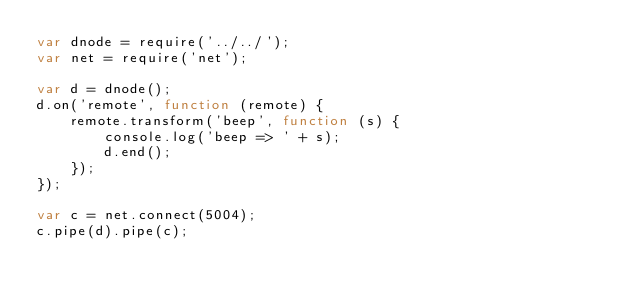<code> <loc_0><loc_0><loc_500><loc_500><_JavaScript_>var dnode = require('../../');
var net = require('net');

var d = dnode();
d.on('remote', function (remote) {
    remote.transform('beep', function (s) {
        console.log('beep => ' + s);
        d.end();
    });
});

var c = net.connect(5004);
c.pipe(d).pipe(c);
</code> 